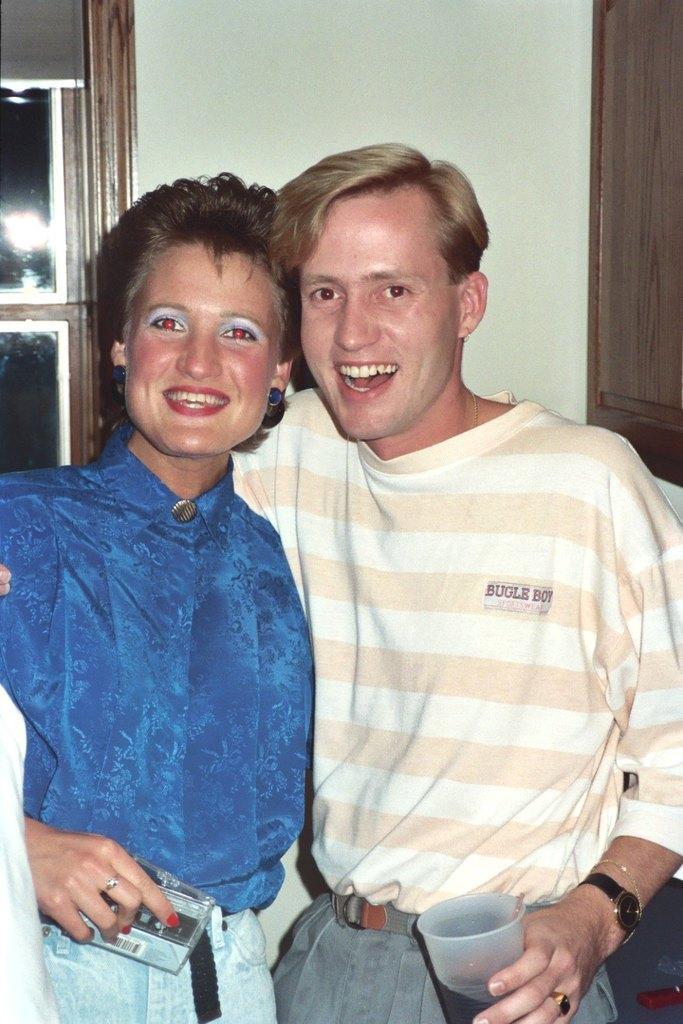In one or two sentences, can you explain what this image depicts? In this image we can see one woman and one man with smiling faces standing near the wall and holding objects. There is one white color object on the bottom left side of the image, one object near the window at the top left side corner of the image, one wooden object looks like a cupboard on the right side of the image, it looks like carpet on the floor and one object on the floor on the bottom right side corner of the image. 